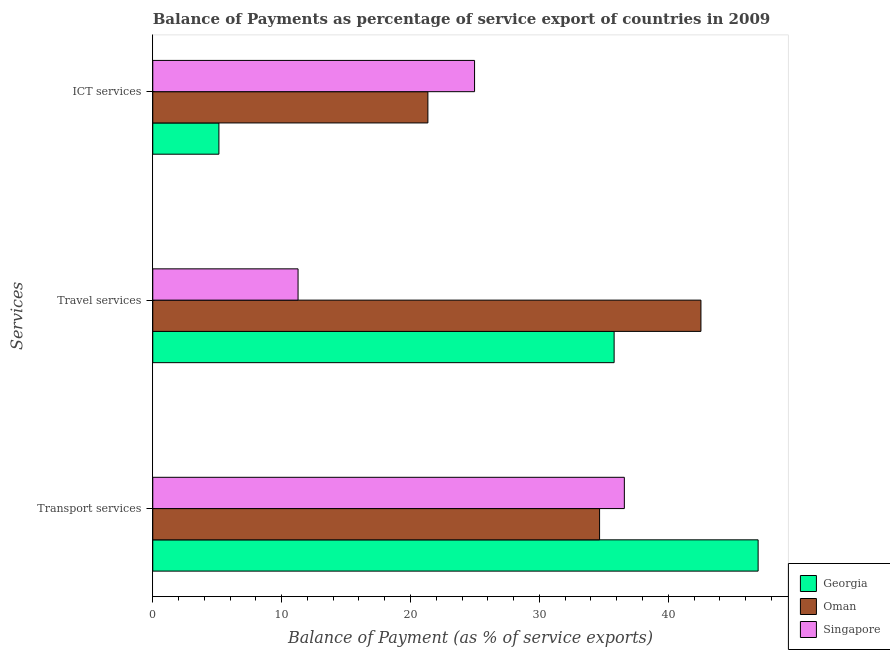How many different coloured bars are there?
Provide a succinct answer. 3. Are the number of bars per tick equal to the number of legend labels?
Keep it short and to the point. Yes. Are the number of bars on each tick of the Y-axis equal?
Offer a very short reply. Yes. How many bars are there on the 2nd tick from the top?
Make the answer very short. 3. What is the label of the 3rd group of bars from the top?
Provide a succinct answer. Transport services. What is the balance of payment of travel services in Singapore?
Your answer should be very brief. 11.27. Across all countries, what is the maximum balance of payment of travel services?
Offer a terse response. 42.54. Across all countries, what is the minimum balance of payment of ict services?
Your response must be concise. 5.13. In which country was the balance of payment of transport services maximum?
Make the answer very short. Georgia. In which country was the balance of payment of ict services minimum?
Keep it short and to the point. Georgia. What is the total balance of payment of transport services in the graph?
Give a very brief answer. 118.24. What is the difference between the balance of payment of transport services in Singapore and that in Georgia?
Offer a very short reply. -10.38. What is the difference between the balance of payment of travel services in Georgia and the balance of payment of transport services in Oman?
Offer a very short reply. 1.13. What is the average balance of payment of travel services per country?
Your response must be concise. 29.87. What is the difference between the balance of payment of transport services and balance of payment of ict services in Singapore?
Provide a succinct answer. 11.62. What is the ratio of the balance of payment of travel services in Georgia to that in Oman?
Keep it short and to the point. 0.84. Is the balance of payment of transport services in Singapore less than that in Georgia?
Your answer should be compact. Yes. What is the difference between the highest and the second highest balance of payment of transport services?
Make the answer very short. 10.38. What is the difference between the highest and the lowest balance of payment of ict services?
Offer a very short reply. 19.84. In how many countries, is the balance of payment of transport services greater than the average balance of payment of transport services taken over all countries?
Provide a short and direct response. 1. Is the sum of the balance of payment of ict services in Singapore and Georgia greater than the maximum balance of payment of transport services across all countries?
Your answer should be very brief. No. What does the 1st bar from the top in ICT services represents?
Keep it short and to the point. Singapore. What does the 2nd bar from the bottom in ICT services represents?
Keep it short and to the point. Oman. How many bars are there?
Give a very brief answer. 9. What is the difference between two consecutive major ticks on the X-axis?
Your response must be concise. 10. Are the values on the major ticks of X-axis written in scientific E-notation?
Provide a succinct answer. No. Does the graph contain any zero values?
Make the answer very short. No. Does the graph contain grids?
Your answer should be compact. No. Where does the legend appear in the graph?
Offer a very short reply. Bottom right. How are the legend labels stacked?
Offer a terse response. Vertical. What is the title of the graph?
Provide a succinct answer. Balance of Payments as percentage of service export of countries in 2009. What is the label or title of the X-axis?
Offer a very short reply. Balance of Payment (as % of service exports). What is the label or title of the Y-axis?
Keep it short and to the point. Services. What is the Balance of Payment (as % of service exports) in Georgia in Transport services?
Provide a succinct answer. 46.97. What is the Balance of Payment (as % of service exports) of Oman in Transport services?
Ensure brevity in your answer.  34.67. What is the Balance of Payment (as % of service exports) of Singapore in Transport services?
Your answer should be compact. 36.59. What is the Balance of Payment (as % of service exports) in Georgia in Travel services?
Provide a short and direct response. 35.8. What is the Balance of Payment (as % of service exports) in Oman in Travel services?
Offer a terse response. 42.54. What is the Balance of Payment (as % of service exports) in Singapore in Travel services?
Offer a very short reply. 11.27. What is the Balance of Payment (as % of service exports) in Georgia in ICT services?
Your answer should be compact. 5.13. What is the Balance of Payment (as % of service exports) of Oman in ICT services?
Your answer should be very brief. 21.35. What is the Balance of Payment (as % of service exports) of Singapore in ICT services?
Your response must be concise. 24.97. Across all Services, what is the maximum Balance of Payment (as % of service exports) in Georgia?
Offer a terse response. 46.97. Across all Services, what is the maximum Balance of Payment (as % of service exports) in Oman?
Provide a short and direct response. 42.54. Across all Services, what is the maximum Balance of Payment (as % of service exports) in Singapore?
Provide a succinct answer. 36.59. Across all Services, what is the minimum Balance of Payment (as % of service exports) of Georgia?
Offer a very short reply. 5.13. Across all Services, what is the minimum Balance of Payment (as % of service exports) in Oman?
Your answer should be very brief. 21.35. Across all Services, what is the minimum Balance of Payment (as % of service exports) in Singapore?
Your answer should be compact. 11.27. What is the total Balance of Payment (as % of service exports) of Georgia in the graph?
Give a very brief answer. 87.9. What is the total Balance of Payment (as % of service exports) in Oman in the graph?
Make the answer very short. 98.56. What is the total Balance of Payment (as % of service exports) of Singapore in the graph?
Provide a short and direct response. 72.84. What is the difference between the Balance of Payment (as % of service exports) of Georgia in Transport services and that in Travel services?
Provide a succinct answer. 11.17. What is the difference between the Balance of Payment (as % of service exports) of Oman in Transport services and that in Travel services?
Give a very brief answer. -7.87. What is the difference between the Balance of Payment (as % of service exports) in Singapore in Transport services and that in Travel services?
Your response must be concise. 25.32. What is the difference between the Balance of Payment (as % of service exports) in Georgia in Transport services and that in ICT services?
Your answer should be very brief. 41.84. What is the difference between the Balance of Payment (as % of service exports) of Oman in Transport services and that in ICT services?
Provide a succinct answer. 13.32. What is the difference between the Balance of Payment (as % of service exports) in Singapore in Transport services and that in ICT services?
Ensure brevity in your answer.  11.62. What is the difference between the Balance of Payment (as % of service exports) of Georgia in Travel services and that in ICT services?
Keep it short and to the point. 30.67. What is the difference between the Balance of Payment (as % of service exports) in Oman in Travel services and that in ICT services?
Your answer should be compact. 21.19. What is the difference between the Balance of Payment (as % of service exports) in Singapore in Travel services and that in ICT services?
Provide a short and direct response. -13.7. What is the difference between the Balance of Payment (as % of service exports) of Georgia in Transport services and the Balance of Payment (as % of service exports) of Oman in Travel services?
Your answer should be compact. 4.44. What is the difference between the Balance of Payment (as % of service exports) in Georgia in Transport services and the Balance of Payment (as % of service exports) in Singapore in Travel services?
Provide a succinct answer. 35.7. What is the difference between the Balance of Payment (as % of service exports) in Oman in Transport services and the Balance of Payment (as % of service exports) in Singapore in Travel services?
Provide a short and direct response. 23.4. What is the difference between the Balance of Payment (as % of service exports) in Georgia in Transport services and the Balance of Payment (as % of service exports) in Oman in ICT services?
Your answer should be compact. 25.63. What is the difference between the Balance of Payment (as % of service exports) of Georgia in Transport services and the Balance of Payment (as % of service exports) of Singapore in ICT services?
Ensure brevity in your answer.  22. What is the difference between the Balance of Payment (as % of service exports) of Oman in Transport services and the Balance of Payment (as % of service exports) of Singapore in ICT services?
Make the answer very short. 9.7. What is the difference between the Balance of Payment (as % of service exports) of Georgia in Travel services and the Balance of Payment (as % of service exports) of Oman in ICT services?
Make the answer very short. 14.45. What is the difference between the Balance of Payment (as % of service exports) of Georgia in Travel services and the Balance of Payment (as % of service exports) of Singapore in ICT services?
Your response must be concise. 10.83. What is the difference between the Balance of Payment (as % of service exports) of Oman in Travel services and the Balance of Payment (as % of service exports) of Singapore in ICT services?
Give a very brief answer. 17.57. What is the average Balance of Payment (as % of service exports) in Georgia per Services?
Your answer should be compact. 29.3. What is the average Balance of Payment (as % of service exports) in Oman per Services?
Ensure brevity in your answer.  32.85. What is the average Balance of Payment (as % of service exports) of Singapore per Services?
Your answer should be very brief. 24.28. What is the difference between the Balance of Payment (as % of service exports) of Georgia and Balance of Payment (as % of service exports) of Oman in Transport services?
Your answer should be compact. 12.3. What is the difference between the Balance of Payment (as % of service exports) in Georgia and Balance of Payment (as % of service exports) in Singapore in Transport services?
Offer a very short reply. 10.38. What is the difference between the Balance of Payment (as % of service exports) in Oman and Balance of Payment (as % of service exports) in Singapore in Transport services?
Your answer should be compact. -1.92. What is the difference between the Balance of Payment (as % of service exports) of Georgia and Balance of Payment (as % of service exports) of Oman in Travel services?
Provide a succinct answer. -6.74. What is the difference between the Balance of Payment (as % of service exports) of Georgia and Balance of Payment (as % of service exports) of Singapore in Travel services?
Ensure brevity in your answer.  24.53. What is the difference between the Balance of Payment (as % of service exports) in Oman and Balance of Payment (as % of service exports) in Singapore in Travel services?
Provide a short and direct response. 31.26. What is the difference between the Balance of Payment (as % of service exports) of Georgia and Balance of Payment (as % of service exports) of Oman in ICT services?
Give a very brief answer. -16.22. What is the difference between the Balance of Payment (as % of service exports) in Georgia and Balance of Payment (as % of service exports) in Singapore in ICT services?
Provide a succinct answer. -19.84. What is the difference between the Balance of Payment (as % of service exports) of Oman and Balance of Payment (as % of service exports) of Singapore in ICT services?
Your answer should be compact. -3.62. What is the ratio of the Balance of Payment (as % of service exports) of Georgia in Transport services to that in Travel services?
Provide a short and direct response. 1.31. What is the ratio of the Balance of Payment (as % of service exports) in Oman in Transport services to that in Travel services?
Give a very brief answer. 0.82. What is the ratio of the Balance of Payment (as % of service exports) in Singapore in Transport services to that in Travel services?
Ensure brevity in your answer.  3.25. What is the ratio of the Balance of Payment (as % of service exports) in Georgia in Transport services to that in ICT services?
Offer a very short reply. 9.15. What is the ratio of the Balance of Payment (as % of service exports) of Oman in Transport services to that in ICT services?
Offer a very short reply. 1.62. What is the ratio of the Balance of Payment (as % of service exports) of Singapore in Transport services to that in ICT services?
Offer a terse response. 1.47. What is the ratio of the Balance of Payment (as % of service exports) in Georgia in Travel services to that in ICT services?
Your answer should be compact. 6.98. What is the ratio of the Balance of Payment (as % of service exports) of Oman in Travel services to that in ICT services?
Provide a short and direct response. 1.99. What is the ratio of the Balance of Payment (as % of service exports) of Singapore in Travel services to that in ICT services?
Your answer should be very brief. 0.45. What is the difference between the highest and the second highest Balance of Payment (as % of service exports) in Georgia?
Provide a short and direct response. 11.17. What is the difference between the highest and the second highest Balance of Payment (as % of service exports) in Oman?
Give a very brief answer. 7.87. What is the difference between the highest and the second highest Balance of Payment (as % of service exports) in Singapore?
Offer a terse response. 11.62. What is the difference between the highest and the lowest Balance of Payment (as % of service exports) in Georgia?
Your answer should be very brief. 41.84. What is the difference between the highest and the lowest Balance of Payment (as % of service exports) in Oman?
Offer a terse response. 21.19. What is the difference between the highest and the lowest Balance of Payment (as % of service exports) of Singapore?
Your response must be concise. 25.32. 